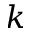Convert formula to latex. <formula><loc_0><loc_0><loc_500><loc_500>k</formula> 